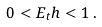<formula> <loc_0><loc_0><loc_500><loc_500>0 < E _ { t } h < 1 \, .</formula> 